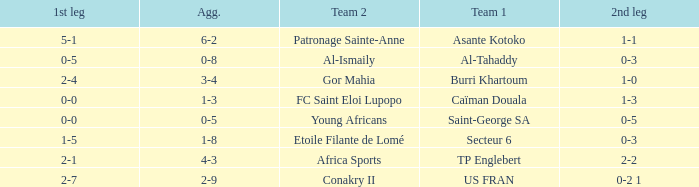Which team lost 0-3 and 0-5? Al-Tahaddy. 